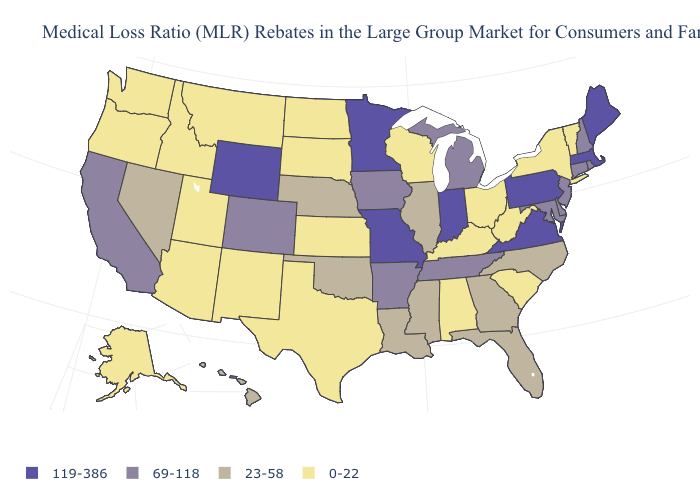What is the value of Massachusetts?
Concise answer only. 119-386. What is the value of Minnesota?
Be succinct. 119-386. What is the highest value in the MidWest ?
Keep it brief. 119-386. What is the value of North Dakota?
Be succinct. 0-22. Does Minnesota have the highest value in the USA?
Keep it brief. Yes. Name the states that have a value in the range 23-58?
Keep it brief. Florida, Georgia, Hawaii, Illinois, Louisiana, Mississippi, Nebraska, Nevada, North Carolina, Oklahoma. What is the highest value in the MidWest ?
Be succinct. 119-386. What is the value of Kentucky?
Write a very short answer. 0-22. What is the lowest value in the USA?
Concise answer only. 0-22. Name the states that have a value in the range 0-22?
Keep it brief. Alabama, Alaska, Arizona, Idaho, Kansas, Kentucky, Montana, New Mexico, New York, North Dakota, Ohio, Oregon, South Carolina, South Dakota, Texas, Utah, Vermont, Washington, West Virginia, Wisconsin. Does Colorado have the lowest value in the West?
Write a very short answer. No. Name the states that have a value in the range 119-386?
Give a very brief answer. Indiana, Maine, Massachusetts, Minnesota, Missouri, Pennsylvania, Virginia, Wyoming. Which states have the lowest value in the USA?
Write a very short answer. Alabama, Alaska, Arizona, Idaho, Kansas, Kentucky, Montana, New Mexico, New York, North Dakota, Ohio, Oregon, South Carolina, South Dakota, Texas, Utah, Vermont, Washington, West Virginia, Wisconsin. Does California have the lowest value in the West?
Give a very brief answer. No. Does Maine have the highest value in the Northeast?
Concise answer only. Yes. 